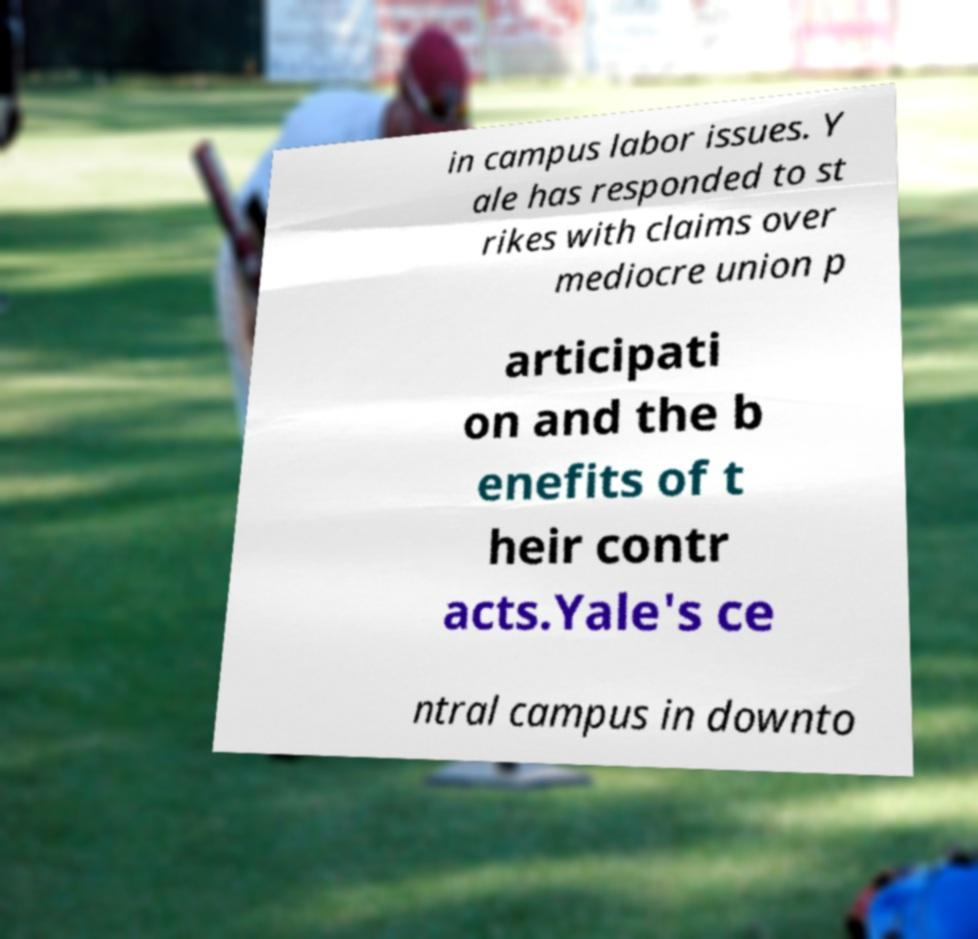Please read and relay the text visible in this image. What does it say? in campus labor issues. Y ale has responded to st rikes with claims over mediocre union p articipati on and the b enefits of t heir contr acts.Yale's ce ntral campus in downto 